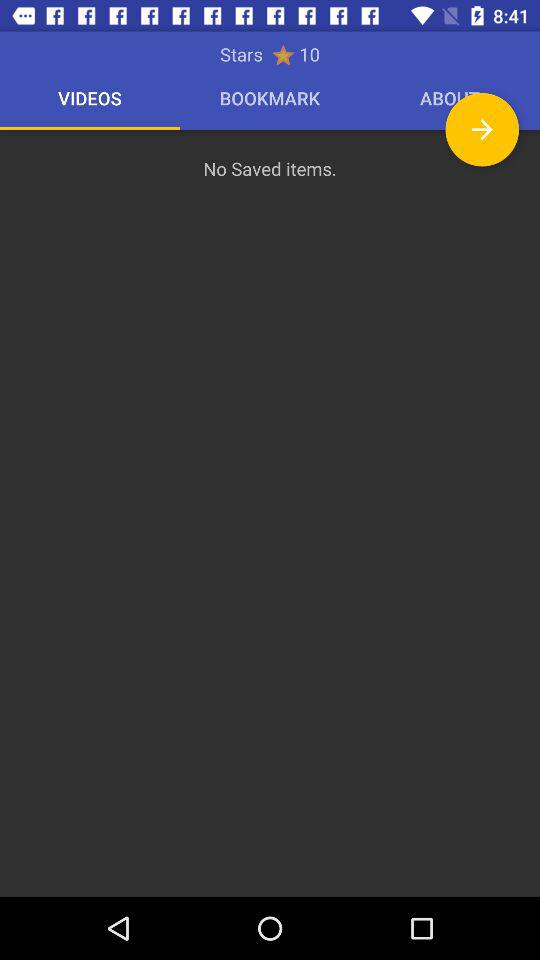How many stars are there? There are 10 stars. 